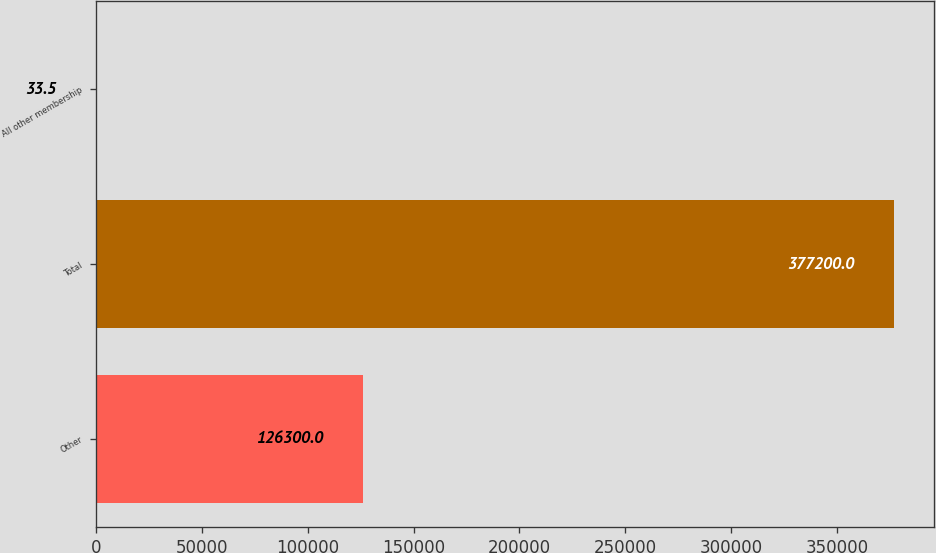<chart> <loc_0><loc_0><loc_500><loc_500><bar_chart><fcel>Other<fcel>Total<fcel>All other membership<nl><fcel>126300<fcel>377200<fcel>33.5<nl></chart> 